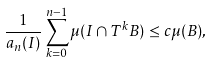<formula> <loc_0><loc_0><loc_500><loc_500>\frac { 1 } { a _ { n } ( I ) } \sum _ { k = 0 } ^ { n - 1 } \mu ( I \cap T ^ { k } B ) \leq c \mu ( B ) ,</formula> 